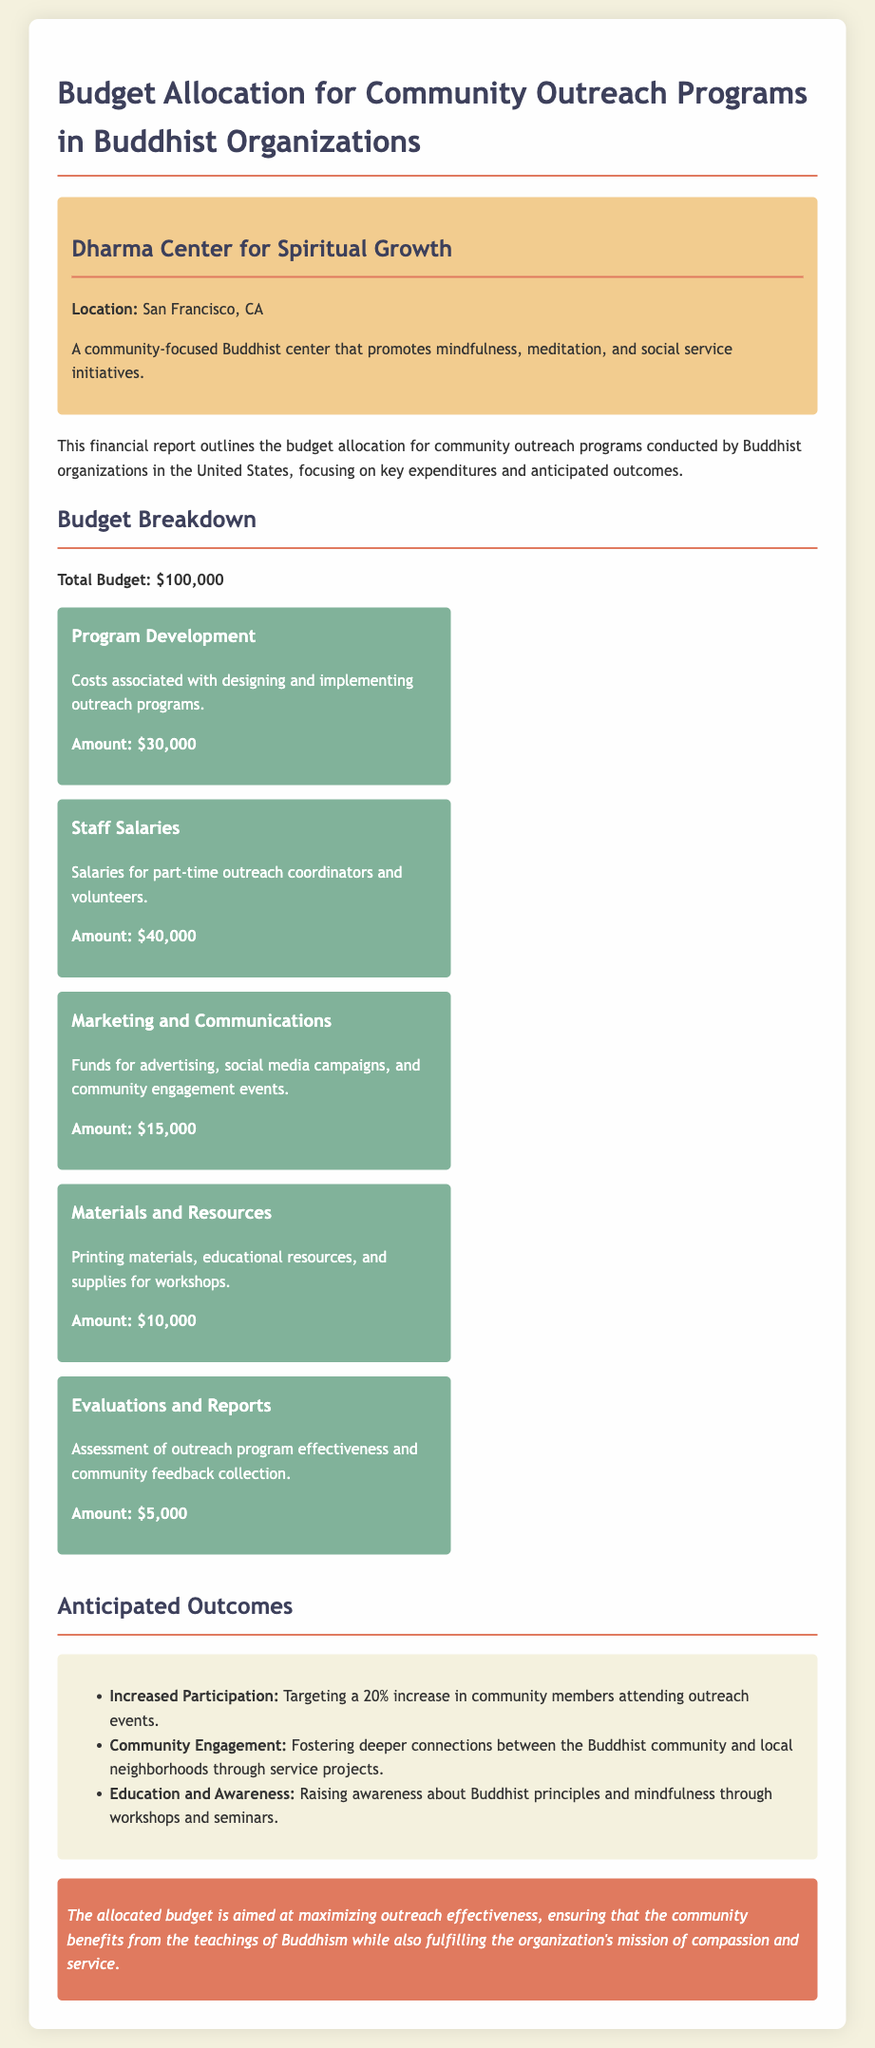what is the total budget? The total budget for the community outreach programs is specified in the document, which is $100,000.
Answer: $100,000 how much is allocated for staff salaries? The document provides a breakdown of costs, indicating that $40,000 is allocated for staff salaries.
Answer: $40,000 what is the purpose of the evaluations and reports budget? The budget item includes an explanation of the purpose, which is to assess outreach program effectiveness and collect community feedback.
Answer: Assessment of outreach program effectiveness and community feedback collection what is the anticipated increase in community participation? The document states the goal for outreach programs is targeting a 20% increase in participation.
Answer: 20% which organization is mentioned in the report? The report highlights the specific organization that is involved in community outreach, which is the Dharma Center for Spiritual Growth.
Answer: Dharma Center for Spiritual Growth what are the expected outcomes regarding education and awareness? The document outlines desired outcomes, mentioning raising awareness about Buddhist principles and mindfulness through various initiatives.
Answer: Raising awareness about Buddhist principles and mindfulness how much is allocated for marketing and communications? The budget item details the cost designated for marketing and communications as $15,000.
Answer: $15,000 what is the location of the Dharma Center for Spiritual Growth? The report includes location details for the organization, which is San Francisco, CA.
Answer: San Francisco, CA what is the main focus of the community outreach initiatives? The report defines the main focus of the initiatives as promoting mindfulness, meditation, and social service.
Answer: Promotes mindfulness, meditation, and social service initiatives 